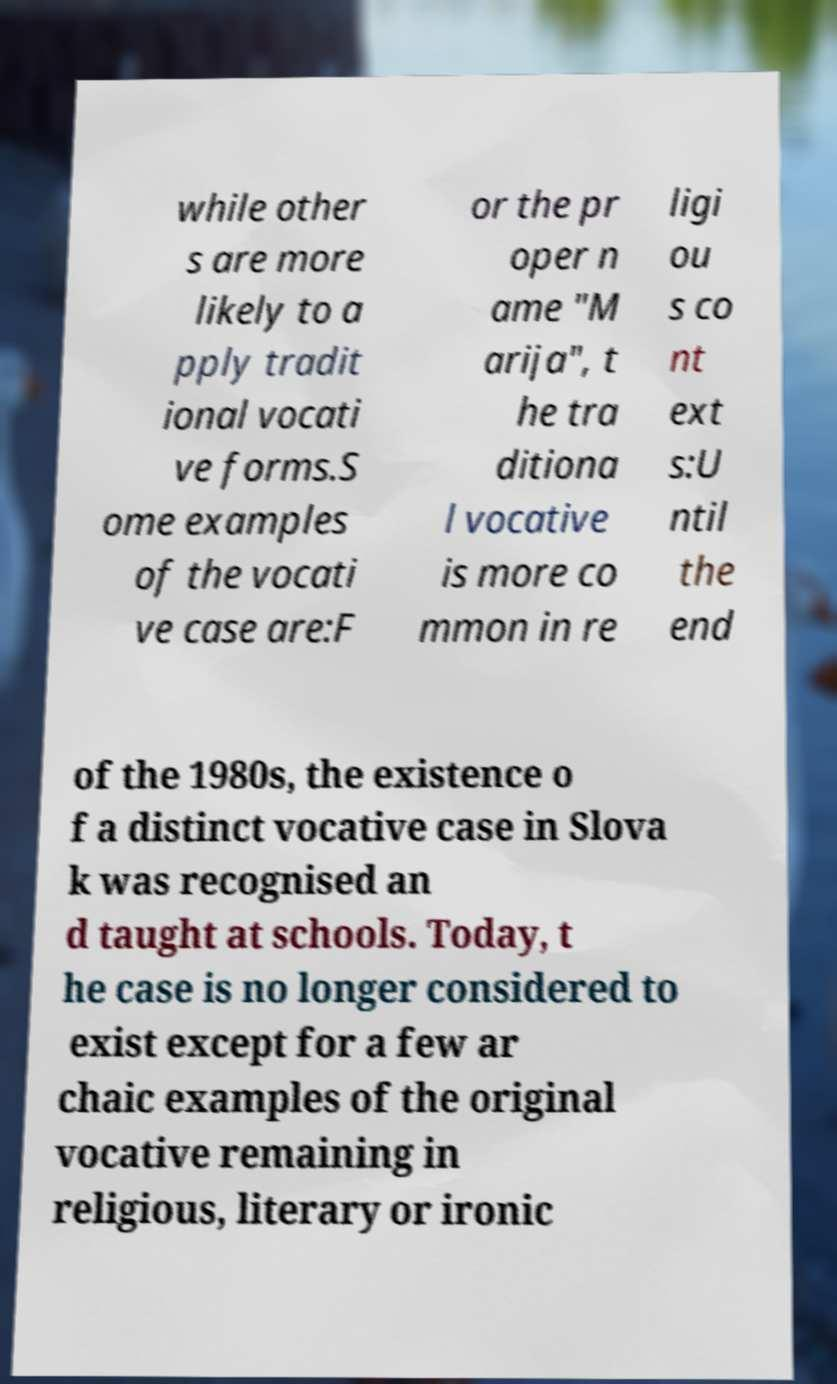Can you accurately transcribe the text from the provided image for me? while other s are more likely to a pply tradit ional vocati ve forms.S ome examples of the vocati ve case are:F or the pr oper n ame "M arija", t he tra ditiona l vocative is more co mmon in re ligi ou s co nt ext s:U ntil the end of the 1980s, the existence o f a distinct vocative case in Slova k was recognised an d taught at schools. Today, t he case is no longer considered to exist except for a few ar chaic examples of the original vocative remaining in religious, literary or ironic 